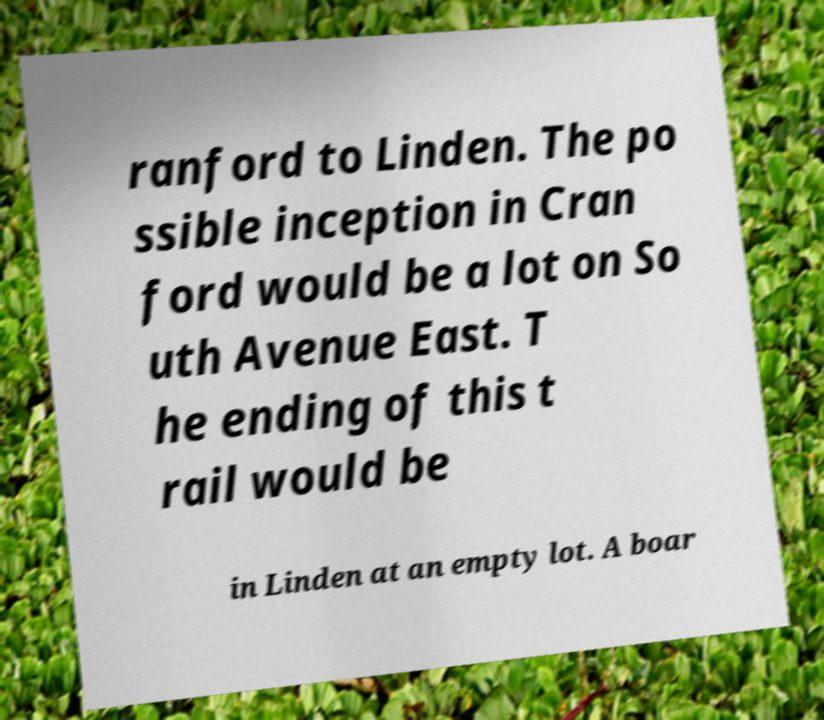Can you read and provide the text displayed in the image?This photo seems to have some interesting text. Can you extract and type it out for me? ranford to Linden. The po ssible inception in Cran ford would be a lot on So uth Avenue East. T he ending of this t rail would be in Linden at an empty lot. A boar 